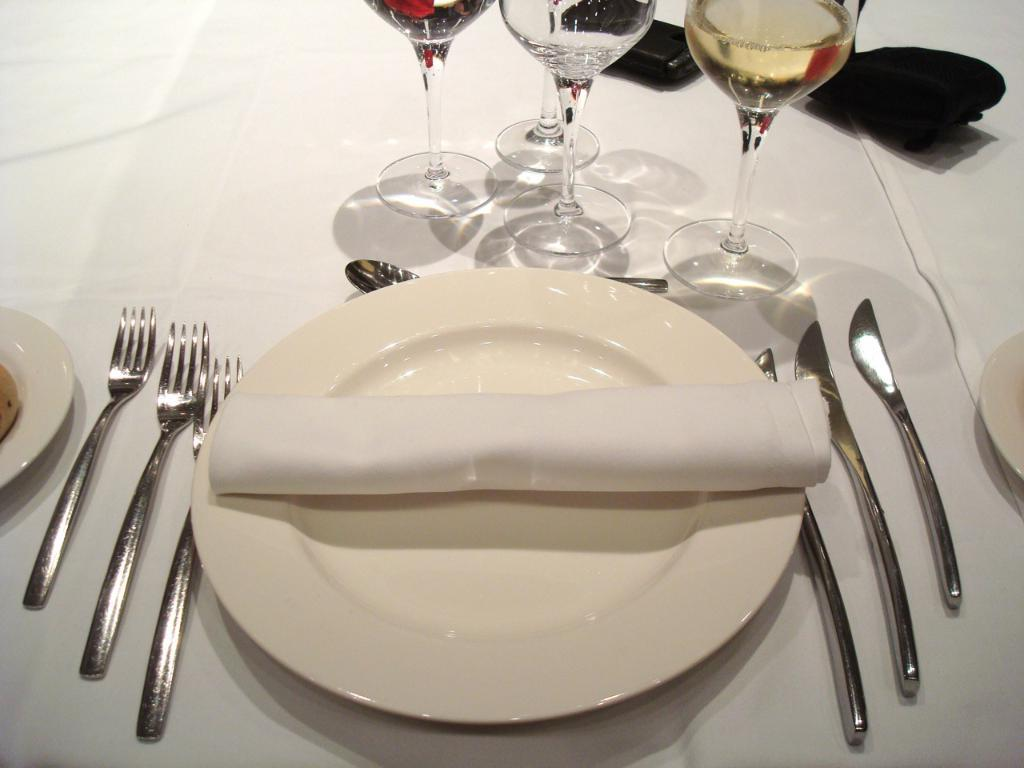What type of tableware can be seen on the table in the image? There are plates, glasses, forks, and spoons on the table in the image. What other objects are present on the table? There are other objects on the table, but their specific details are not mentioned in the provided facts. How many types of tableware are visible on the table? There are four types of tableware visible on the table: plates, glasses, forks, and spoons. Can you describe the cemetery located near the table in the image? There is no cemetery present in the image; it only shows tableware items on a table. What type of pocket is visible on the table in the image? There is no pocket present in the image; it only shows tableware items on a table. 